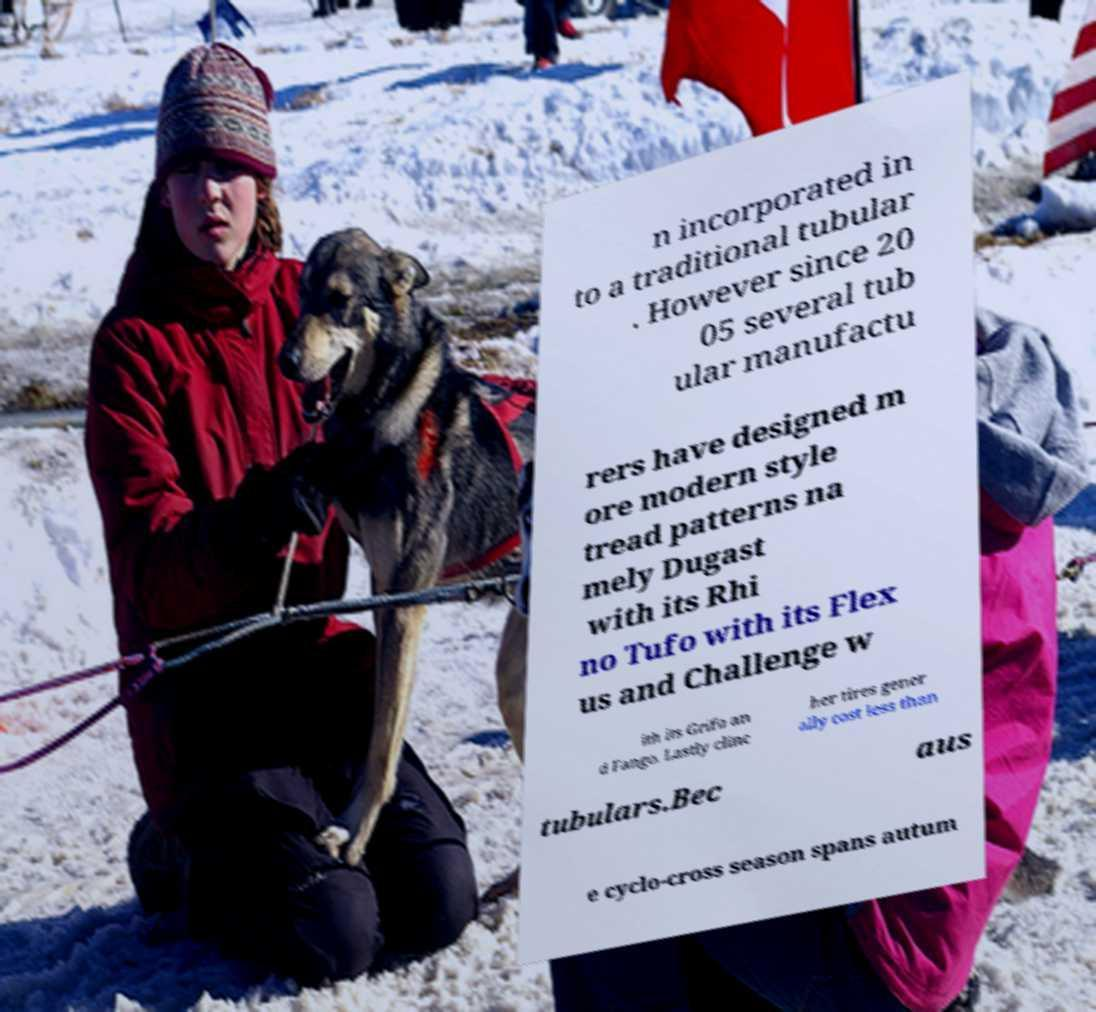Can you accurately transcribe the text from the provided image for me? n incorporated in to a traditional tubular . However since 20 05 several tub ular manufactu rers have designed m ore modern style tread patterns na mely Dugast with its Rhi no Tufo with its Flex us and Challenge w ith its Grifo an d Fango. Lastly clinc her tires gener ally cost less than tubulars.Bec aus e cyclo-cross season spans autum 